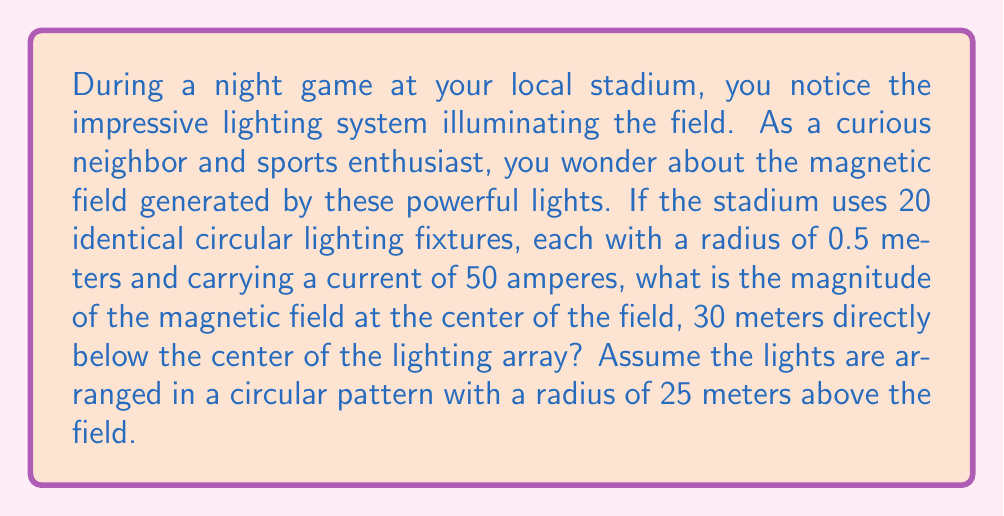Can you solve this math problem? Let's approach this step-by-step:

1) First, we need to use the Biot-Savart law for a circular current loop. The magnetic field at a point on the axis of a current loop is given by:

   $$B = \frac{\mu_0 I R^2}{2(R^2 + z^2)^{3/2}}$$

   Where:
   $\mu_0$ is the permeability of free space ($4\pi \times 10^{-7}$ T⋅m/A)
   $I$ is the current
   $R$ is the radius of the loop
   $z$ is the distance from the loop to the point on the axis

2) In our case, we have 20 identical fixtures. The field at the center point will be the sum of the contributions from all 20 fixtures.

3) For each fixture:
   $I = 50$ A
   $R = 0.5$ m
   $z = \sqrt{30^2 + 25^2} = \sqrt{1525} \approx 39.05$ m (using the Pythagorean theorem)

4) Substituting these values:

   $$B_{single} = \frac{4\pi \times 10^{-7} \times 50 \times 0.5^2}{2(0.5^2 + 39.05^2)^{3/2}}$$

5) Simplifying:

   $$B_{single} \approx 1.6439 \times 10^{-9}$$ T

6) Since there are 20 identical fixtures, and their fields all point in the same direction at the center point, we multiply this by 20:

   $$B_{total} = 20 \times 1.6439 \times 10^{-9} \approx 3.2878 \times 10^{-8}$$ T

7) Convert to nanotesla:

   $$B_{total} \approx 32.878$$ nT
Answer: 32.878 nT 